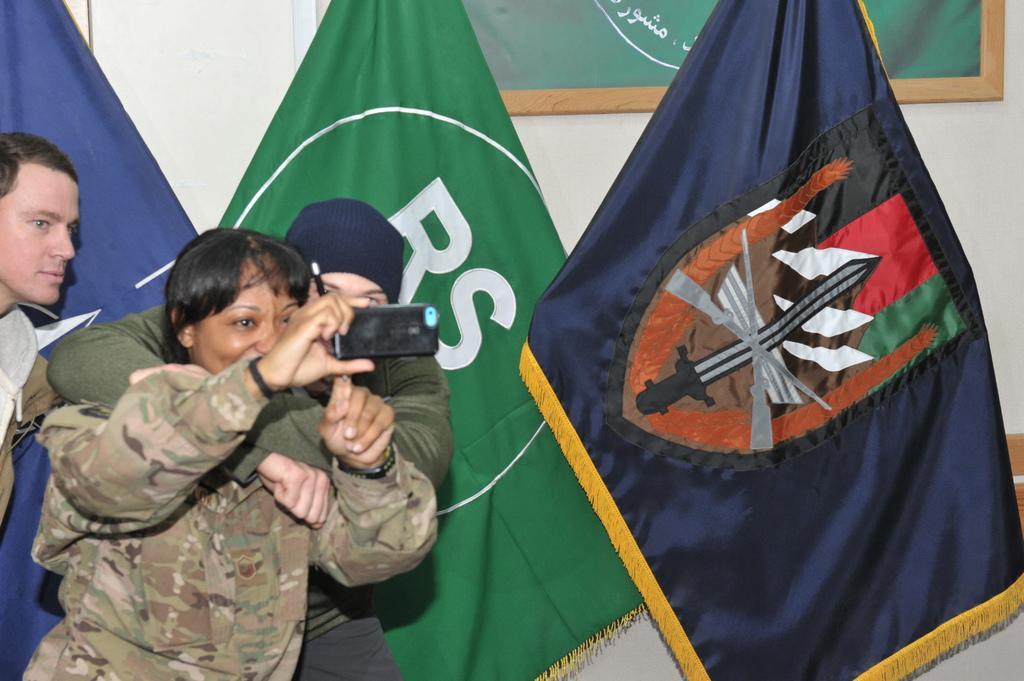Can you describe this image briefly? There are people and this person holding mobile and pen. In the background we can see flags and board on a wall. 